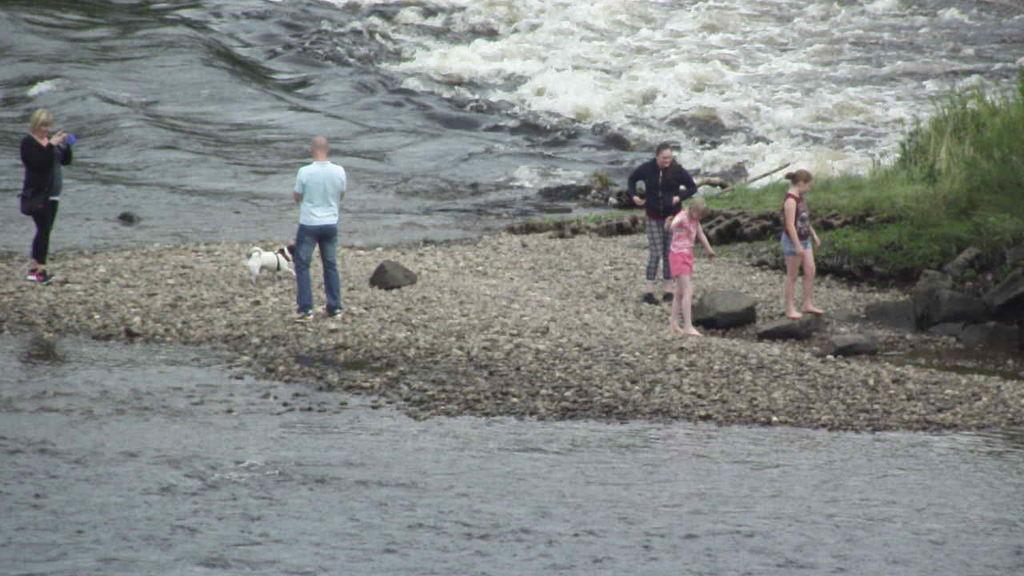What can be seen in the image in terms of living beings? There are people standing in the image, and a dog is also present. What is the environment like in the image? There is water visible in the image, as well as grass and small stones on the ground. What type of plants can be seen growing in the pot in the image? There is no pot or plants present in the image. How many seats are visible in the image? There are no seats visible in the image. 